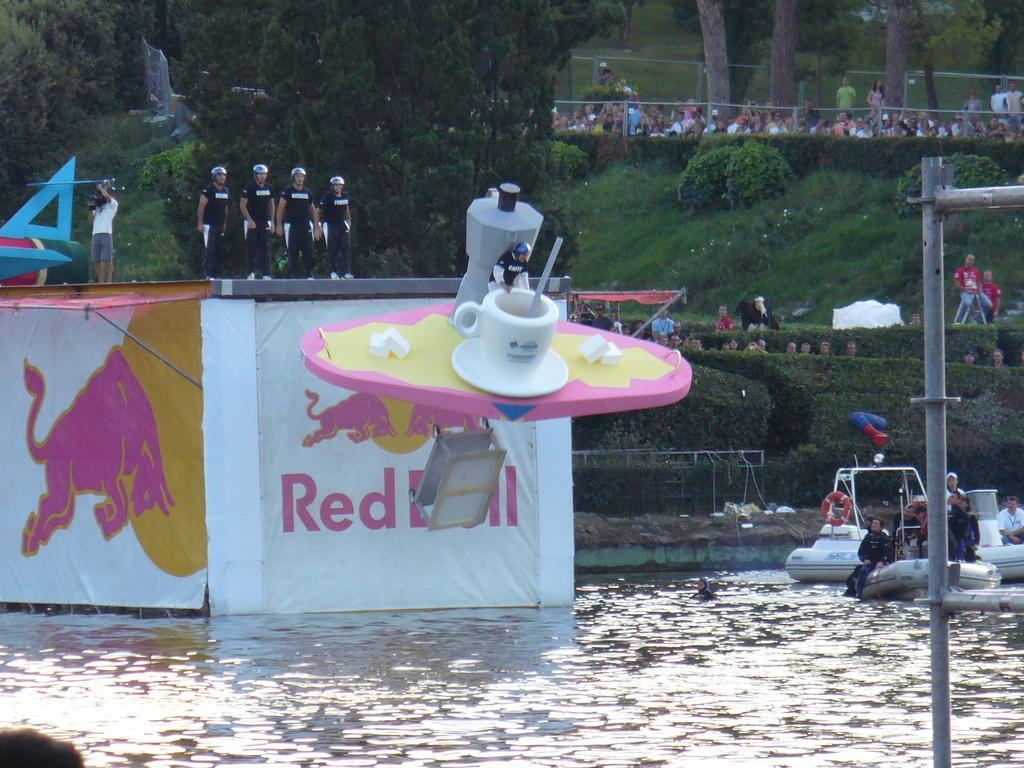Can you describe this image briefly? In this image we can see a few people, some of them are sitting on the boats, some of them are on the platform, we can see a big cup, there are some plants, trees, posters with some images and text onnit, grass, also we can see some poles, water. 